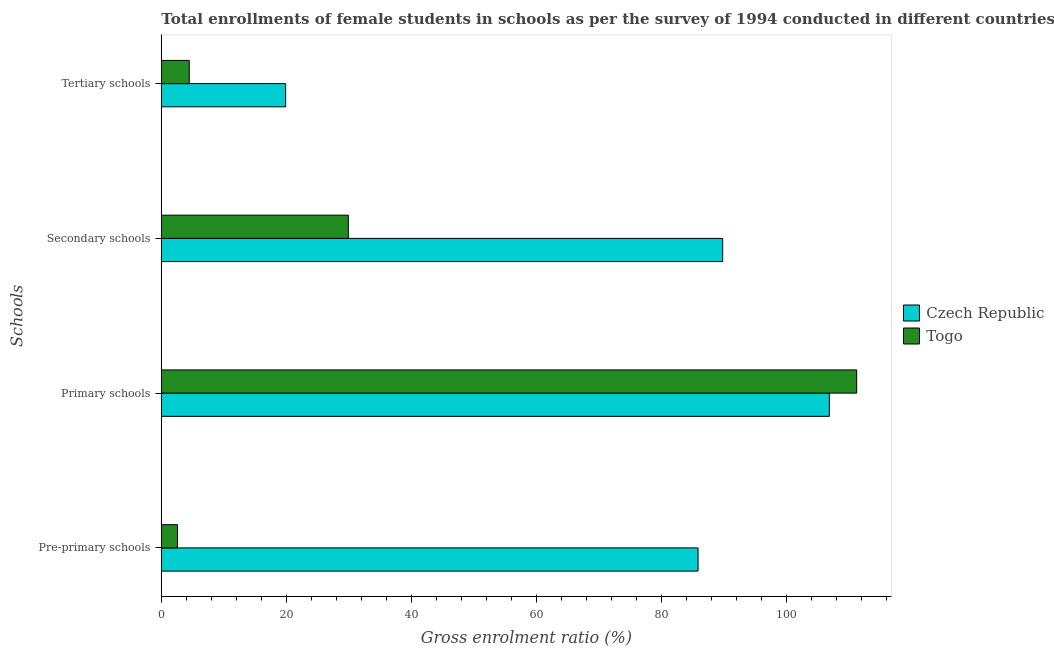How many different coloured bars are there?
Your answer should be compact. 2. How many groups of bars are there?
Ensure brevity in your answer.  4. Are the number of bars on each tick of the Y-axis equal?
Offer a very short reply. Yes. What is the label of the 1st group of bars from the top?
Provide a short and direct response. Tertiary schools. What is the gross enrolment ratio(female) in pre-primary schools in Czech Republic?
Keep it short and to the point. 85.88. Across all countries, what is the maximum gross enrolment ratio(female) in pre-primary schools?
Provide a succinct answer. 85.88. Across all countries, what is the minimum gross enrolment ratio(female) in secondary schools?
Your answer should be compact. 29.92. In which country was the gross enrolment ratio(female) in primary schools maximum?
Offer a terse response. Togo. In which country was the gross enrolment ratio(female) in pre-primary schools minimum?
Provide a short and direct response. Togo. What is the total gross enrolment ratio(female) in secondary schools in the graph?
Your answer should be compact. 119.74. What is the difference between the gross enrolment ratio(female) in pre-primary schools in Togo and that in Czech Republic?
Your answer should be compact. -83.3. What is the difference between the gross enrolment ratio(female) in primary schools in Togo and the gross enrolment ratio(female) in tertiary schools in Czech Republic?
Offer a very short reply. 91.37. What is the average gross enrolment ratio(female) in secondary schools per country?
Provide a succinct answer. 59.87. What is the difference between the gross enrolment ratio(female) in primary schools and gross enrolment ratio(female) in secondary schools in Czech Republic?
Your response must be concise. 17.06. In how many countries, is the gross enrolment ratio(female) in secondary schools greater than 12 %?
Your response must be concise. 2. What is the ratio of the gross enrolment ratio(female) in pre-primary schools in Czech Republic to that in Togo?
Your answer should be very brief. 33.24. Is the gross enrolment ratio(female) in tertiary schools in Togo less than that in Czech Republic?
Make the answer very short. Yes. What is the difference between the highest and the second highest gross enrolment ratio(female) in primary schools?
Give a very brief answer. 4.38. What is the difference between the highest and the lowest gross enrolment ratio(female) in pre-primary schools?
Give a very brief answer. 83.3. In how many countries, is the gross enrolment ratio(female) in secondary schools greater than the average gross enrolment ratio(female) in secondary schools taken over all countries?
Ensure brevity in your answer.  1. Is the sum of the gross enrolment ratio(female) in pre-primary schools in Czech Republic and Togo greater than the maximum gross enrolment ratio(female) in tertiary schools across all countries?
Ensure brevity in your answer.  Yes. What does the 1st bar from the top in Secondary schools represents?
Your response must be concise. Togo. What does the 2nd bar from the bottom in Secondary schools represents?
Make the answer very short. Togo. How many countries are there in the graph?
Make the answer very short. 2. What is the difference between two consecutive major ticks on the X-axis?
Give a very brief answer. 20. Are the values on the major ticks of X-axis written in scientific E-notation?
Ensure brevity in your answer.  No. Where does the legend appear in the graph?
Ensure brevity in your answer.  Center right. How many legend labels are there?
Your answer should be very brief. 2. How are the legend labels stacked?
Give a very brief answer. Vertical. What is the title of the graph?
Your answer should be compact. Total enrollments of female students in schools as per the survey of 1994 conducted in different countries. What is the label or title of the Y-axis?
Keep it short and to the point. Schools. What is the Gross enrolment ratio (%) in Czech Republic in Pre-primary schools?
Keep it short and to the point. 85.88. What is the Gross enrolment ratio (%) in Togo in Pre-primary schools?
Give a very brief answer. 2.58. What is the Gross enrolment ratio (%) in Czech Republic in Primary schools?
Offer a very short reply. 106.89. What is the Gross enrolment ratio (%) of Togo in Primary schools?
Provide a succinct answer. 111.26. What is the Gross enrolment ratio (%) in Czech Republic in Secondary schools?
Your answer should be very brief. 89.82. What is the Gross enrolment ratio (%) in Togo in Secondary schools?
Ensure brevity in your answer.  29.92. What is the Gross enrolment ratio (%) in Czech Republic in Tertiary schools?
Make the answer very short. 19.89. What is the Gross enrolment ratio (%) in Togo in Tertiary schools?
Your answer should be very brief. 4.47. Across all Schools, what is the maximum Gross enrolment ratio (%) of Czech Republic?
Provide a short and direct response. 106.89. Across all Schools, what is the maximum Gross enrolment ratio (%) in Togo?
Make the answer very short. 111.26. Across all Schools, what is the minimum Gross enrolment ratio (%) of Czech Republic?
Make the answer very short. 19.89. Across all Schools, what is the minimum Gross enrolment ratio (%) of Togo?
Offer a terse response. 2.58. What is the total Gross enrolment ratio (%) in Czech Republic in the graph?
Provide a short and direct response. 302.49. What is the total Gross enrolment ratio (%) of Togo in the graph?
Provide a succinct answer. 148.24. What is the difference between the Gross enrolment ratio (%) in Czech Republic in Pre-primary schools and that in Primary schools?
Offer a terse response. -21. What is the difference between the Gross enrolment ratio (%) in Togo in Pre-primary schools and that in Primary schools?
Ensure brevity in your answer.  -108.68. What is the difference between the Gross enrolment ratio (%) in Czech Republic in Pre-primary schools and that in Secondary schools?
Your answer should be compact. -3.94. What is the difference between the Gross enrolment ratio (%) in Togo in Pre-primary schools and that in Secondary schools?
Keep it short and to the point. -27.34. What is the difference between the Gross enrolment ratio (%) of Czech Republic in Pre-primary schools and that in Tertiary schools?
Your answer should be very brief. 65.99. What is the difference between the Gross enrolment ratio (%) of Togo in Pre-primary schools and that in Tertiary schools?
Your answer should be very brief. -1.89. What is the difference between the Gross enrolment ratio (%) of Czech Republic in Primary schools and that in Secondary schools?
Provide a short and direct response. 17.06. What is the difference between the Gross enrolment ratio (%) in Togo in Primary schools and that in Secondary schools?
Ensure brevity in your answer.  81.34. What is the difference between the Gross enrolment ratio (%) in Czech Republic in Primary schools and that in Tertiary schools?
Your answer should be compact. 86.99. What is the difference between the Gross enrolment ratio (%) in Togo in Primary schools and that in Tertiary schools?
Provide a short and direct response. 106.79. What is the difference between the Gross enrolment ratio (%) in Czech Republic in Secondary schools and that in Tertiary schools?
Provide a short and direct response. 69.93. What is the difference between the Gross enrolment ratio (%) in Togo in Secondary schools and that in Tertiary schools?
Give a very brief answer. 25.45. What is the difference between the Gross enrolment ratio (%) of Czech Republic in Pre-primary schools and the Gross enrolment ratio (%) of Togo in Primary schools?
Offer a very short reply. -25.38. What is the difference between the Gross enrolment ratio (%) of Czech Republic in Pre-primary schools and the Gross enrolment ratio (%) of Togo in Secondary schools?
Keep it short and to the point. 55.96. What is the difference between the Gross enrolment ratio (%) in Czech Republic in Pre-primary schools and the Gross enrolment ratio (%) in Togo in Tertiary schools?
Your answer should be compact. 81.41. What is the difference between the Gross enrolment ratio (%) of Czech Republic in Primary schools and the Gross enrolment ratio (%) of Togo in Secondary schools?
Offer a very short reply. 76.97. What is the difference between the Gross enrolment ratio (%) in Czech Republic in Primary schools and the Gross enrolment ratio (%) in Togo in Tertiary schools?
Offer a very short reply. 102.42. What is the difference between the Gross enrolment ratio (%) in Czech Republic in Secondary schools and the Gross enrolment ratio (%) in Togo in Tertiary schools?
Your answer should be very brief. 85.35. What is the average Gross enrolment ratio (%) in Czech Republic per Schools?
Your answer should be very brief. 75.62. What is the average Gross enrolment ratio (%) in Togo per Schools?
Offer a terse response. 37.06. What is the difference between the Gross enrolment ratio (%) in Czech Republic and Gross enrolment ratio (%) in Togo in Pre-primary schools?
Your answer should be very brief. 83.3. What is the difference between the Gross enrolment ratio (%) in Czech Republic and Gross enrolment ratio (%) in Togo in Primary schools?
Make the answer very short. -4.38. What is the difference between the Gross enrolment ratio (%) of Czech Republic and Gross enrolment ratio (%) of Togo in Secondary schools?
Your answer should be compact. 59.9. What is the difference between the Gross enrolment ratio (%) of Czech Republic and Gross enrolment ratio (%) of Togo in Tertiary schools?
Provide a succinct answer. 15.42. What is the ratio of the Gross enrolment ratio (%) in Czech Republic in Pre-primary schools to that in Primary schools?
Ensure brevity in your answer.  0.8. What is the ratio of the Gross enrolment ratio (%) of Togo in Pre-primary schools to that in Primary schools?
Offer a very short reply. 0.02. What is the ratio of the Gross enrolment ratio (%) in Czech Republic in Pre-primary schools to that in Secondary schools?
Keep it short and to the point. 0.96. What is the ratio of the Gross enrolment ratio (%) in Togo in Pre-primary schools to that in Secondary schools?
Your response must be concise. 0.09. What is the ratio of the Gross enrolment ratio (%) of Czech Republic in Pre-primary schools to that in Tertiary schools?
Your answer should be compact. 4.32. What is the ratio of the Gross enrolment ratio (%) of Togo in Pre-primary schools to that in Tertiary schools?
Make the answer very short. 0.58. What is the ratio of the Gross enrolment ratio (%) of Czech Republic in Primary schools to that in Secondary schools?
Make the answer very short. 1.19. What is the ratio of the Gross enrolment ratio (%) of Togo in Primary schools to that in Secondary schools?
Offer a very short reply. 3.72. What is the ratio of the Gross enrolment ratio (%) of Czech Republic in Primary schools to that in Tertiary schools?
Your answer should be very brief. 5.37. What is the ratio of the Gross enrolment ratio (%) of Togo in Primary schools to that in Tertiary schools?
Your answer should be very brief. 24.89. What is the ratio of the Gross enrolment ratio (%) in Czech Republic in Secondary schools to that in Tertiary schools?
Ensure brevity in your answer.  4.51. What is the ratio of the Gross enrolment ratio (%) of Togo in Secondary schools to that in Tertiary schools?
Keep it short and to the point. 6.69. What is the difference between the highest and the second highest Gross enrolment ratio (%) of Czech Republic?
Your answer should be very brief. 17.06. What is the difference between the highest and the second highest Gross enrolment ratio (%) of Togo?
Your response must be concise. 81.34. What is the difference between the highest and the lowest Gross enrolment ratio (%) of Czech Republic?
Your response must be concise. 86.99. What is the difference between the highest and the lowest Gross enrolment ratio (%) of Togo?
Make the answer very short. 108.68. 